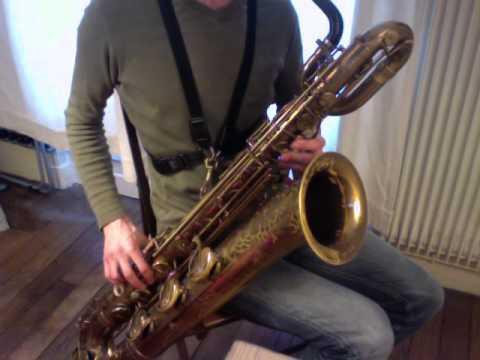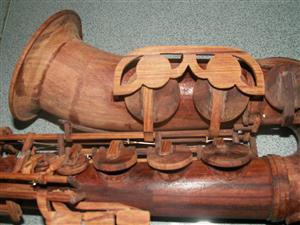The first image is the image on the left, the second image is the image on the right. Considering the images on both sides, is "The left image shows one instrument on a white background." valid? Answer yes or no. No. 